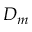Convert formula to latex. <formula><loc_0><loc_0><loc_500><loc_500>D _ { m }</formula> 